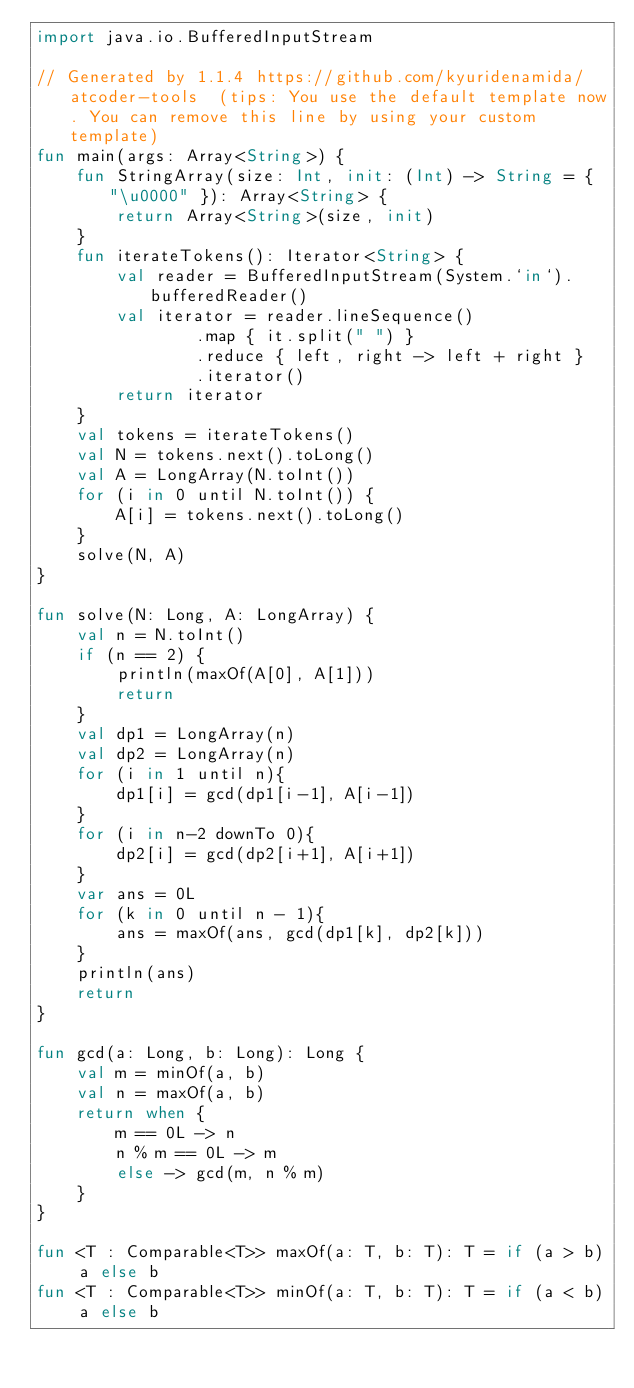Convert code to text. <code><loc_0><loc_0><loc_500><loc_500><_Kotlin_>import java.io.BufferedInputStream

// Generated by 1.1.4 https://github.com/kyuridenamida/atcoder-tools  (tips: You use the default template now. You can remove this line by using your custom template)
fun main(args: Array<String>) {
    fun StringArray(size: Int, init: (Int) -> String = { "\u0000" }): Array<String> {
        return Array<String>(size, init)
    }
    fun iterateTokens(): Iterator<String> {
        val reader = BufferedInputStream(System.`in`).bufferedReader()
        val iterator = reader.lineSequence()
                .map { it.split(" ") }
                .reduce { left, right -> left + right }
                .iterator()
        return iterator
    }
    val tokens = iterateTokens()
    val N = tokens.next().toLong()
    val A = LongArray(N.toInt())
    for (i in 0 until N.toInt()) {
        A[i] = tokens.next().toLong()
    }
    solve(N, A)
}

fun solve(N: Long, A: LongArray) {
    val n = N.toInt()
    if (n == 2) {
        println(maxOf(A[0], A[1]))
        return
    }
    val dp1 = LongArray(n)
    val dp2 = LongArray(n)
    for (i in 1 until n){
        dp1[i] = gcd(dp1[i-1], A[i-1])
    }
    for (i in n-2 downTo 0){
        dp2[i] = gcd(dp2[i+1], A[i+1])
    }
    var ans = 0L
    for (k in 0 until n - 1){
        ans = maxOf(ans, gcd(dp1[k], dp2[k]))
    }
    println(ans)
    return
}

fun gcd(a: Long, b: Long): Long {
    val m = minOf(a, b)
    val n = maxOf(a, b)
    return when {
        m == 0L -> n
        n % m == 0L -> m
        else -> gcd(m, n % m)
    }
}

fun <T : Comparable<T>> maxOf(a: T, b: T): T = if (a > b) a else b
fun <T : Comparable<T>> minOf(a: T, b: T): T = if (a < b) a else b</code> 